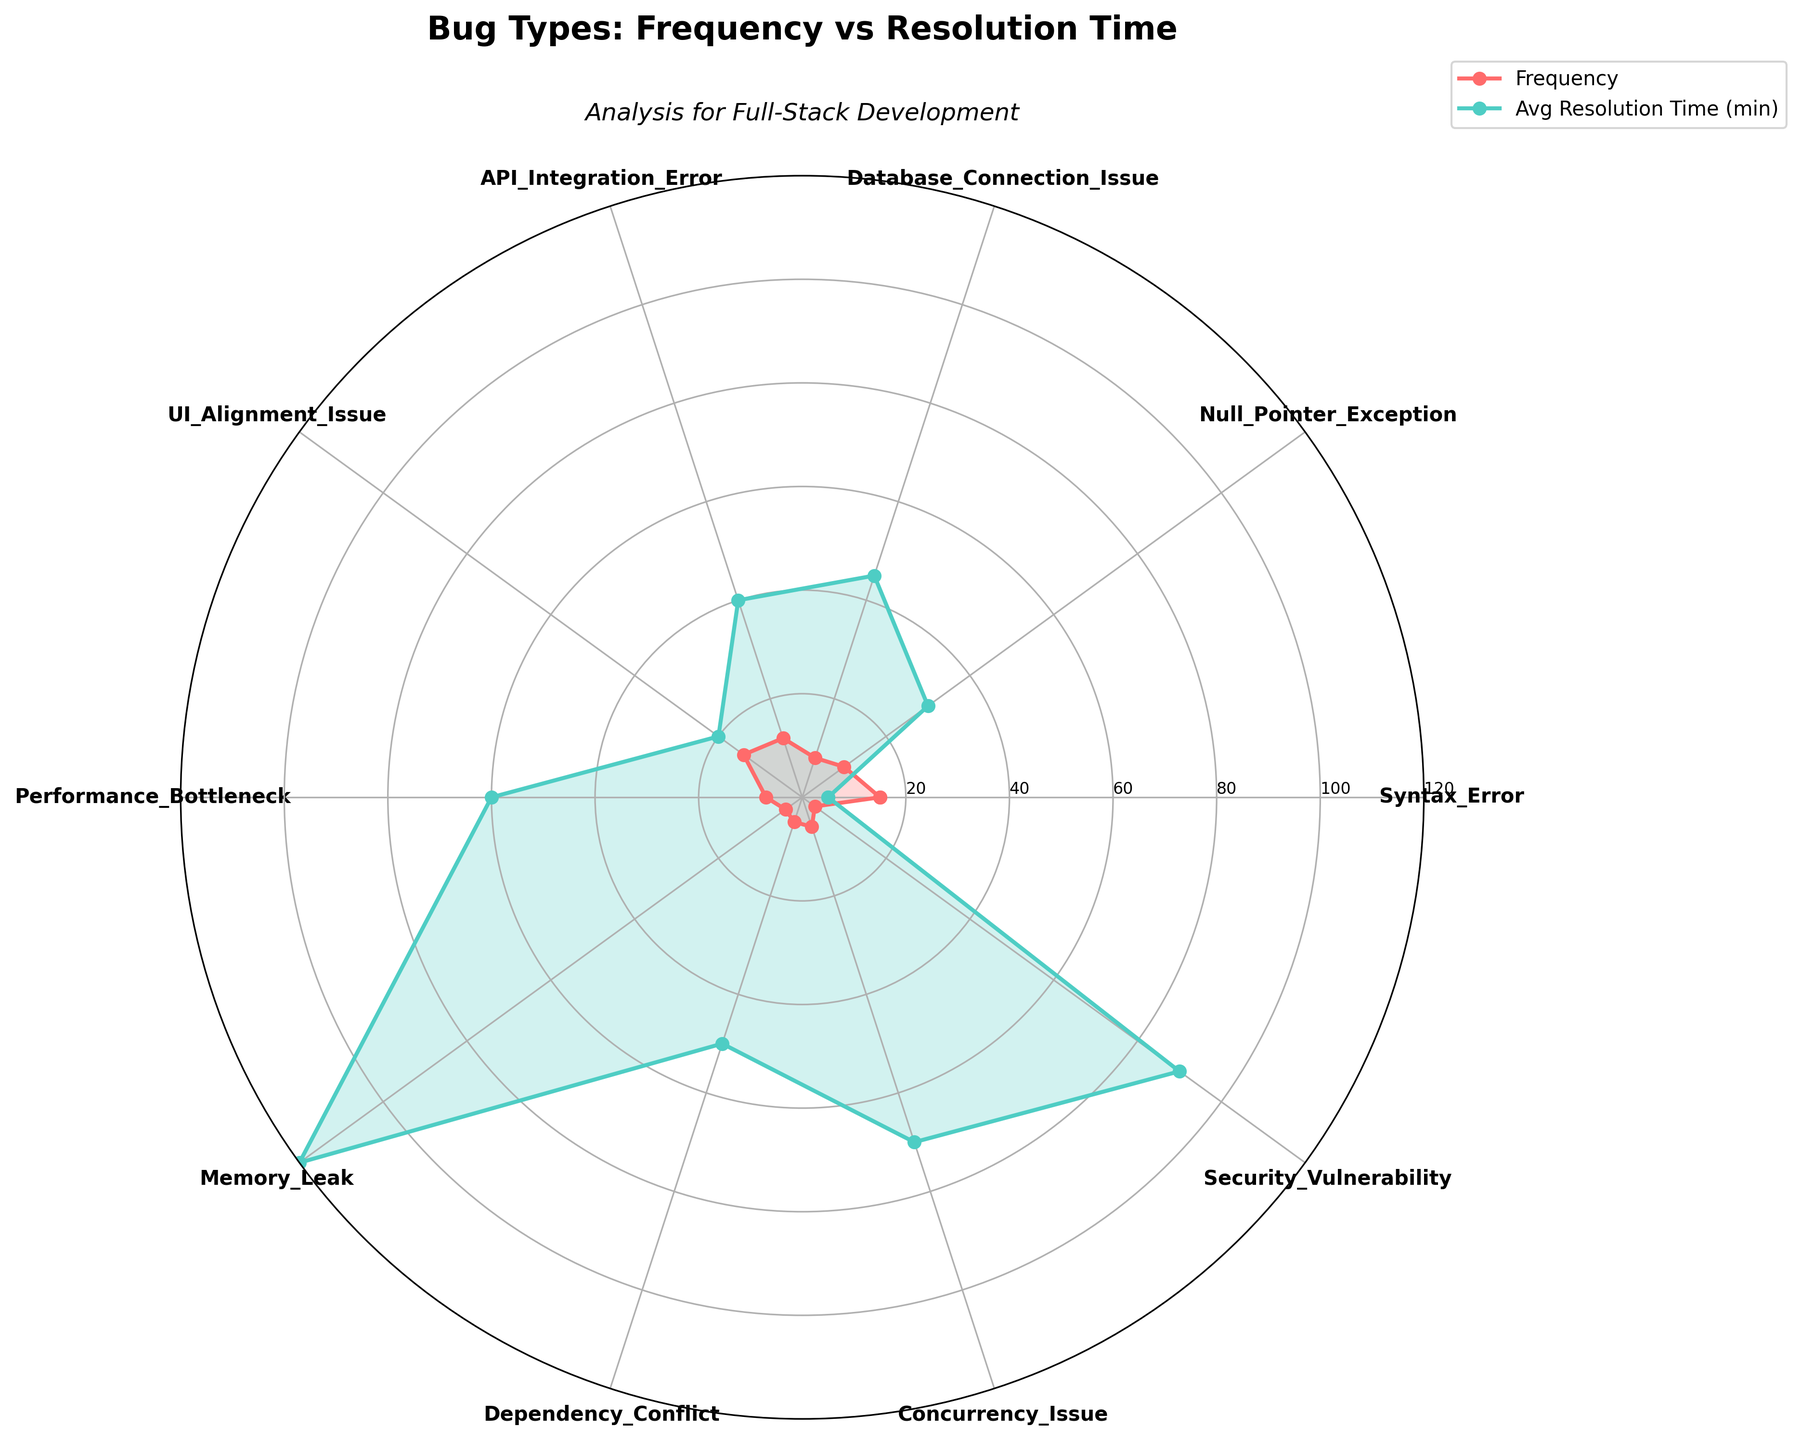What's the title of the chart? The title is written at the top of the chart to convey the main subject, which is the frequency of various bug types and their resolution times.
Answer: Bug Types: Frequency vs Resolution Time What is the subtitle of the chart? The subtitle is placed below the main title to provide additional context about the chart's focus. It relates to full-stack development.
Answer: Analysis for Full-Stack Development Which bug type has the highest frequency? By examining the polar plot and identifying the bug type with the largest radial distance in the frequency plot, we can determine the highest frequency.
Answer: Syntax_Error Which bug type has the longest average resolution time? By looking at the plot and finding the bug type with the largest radial distance in the resolution time plot, we can identify the one with the longest average resolution time.
Answer: Memory_Leak How many ticks are there on the radial axis and what do they represent? The radial axis has six ticks, each representing different levels of values. They mark intervals from the center outward, indicating measurement levels such as 20, 40, 60, 80, 100, and 120.
Answer: Six ticks representing increments of 20 up to 120 Compare the frequency of Null Pointer Exceptions and UI Alignment Issues. Which is higher? By comparing the radial distances for Null Pointer Exceptions and UI Alignment Issues on the frequency plot, we observe that UI Alignment Issues have a larger radial distance, indicating a higher frequency.
Answer: UI Alignment Issue Which bug types have a frequency of at least 10? By identifying the bug types with radial distances corresponding to frequencies of 10 or more, we can list these bug types: Syntax Error, Null Pointer Exception, API Integration Error, and UI Alignment Issue.
Answer: Syntax_Error, Null_Pointer_Exception, API_Integration_Error, UI_Alignment_Issue What is the difference between the average resolution times of Performance Bottlenecks and Database Connection Issues? By checking the radial distances for both Performance Bottlenecks (60 minutes) and Database Connection Issues (45 minutes) in the resolution time plot and subtracting, we get 60 - 45 = 15 minutes.
Answer: 15 minutes Which bug type has a similar frequency and average resolution time? By identifying which bug type has almost equal radial distances in both frequency and resolution time plots, we find only UI Alignment Issue with frequency around 14 and average resolution time around 20 minutes.
Answer: UI Alignment Issue Is the average resolution time for Security Vulnerabilities higher or lower than that for Dependency Conflicts? By comparing the radial distances of Security Vulnerabilities and Dependency Conflicts on the resolution time plot, we observe that Security Vulnerabilities have a higher radial distance, thus a higher average resolution time.
Answer: Higher 